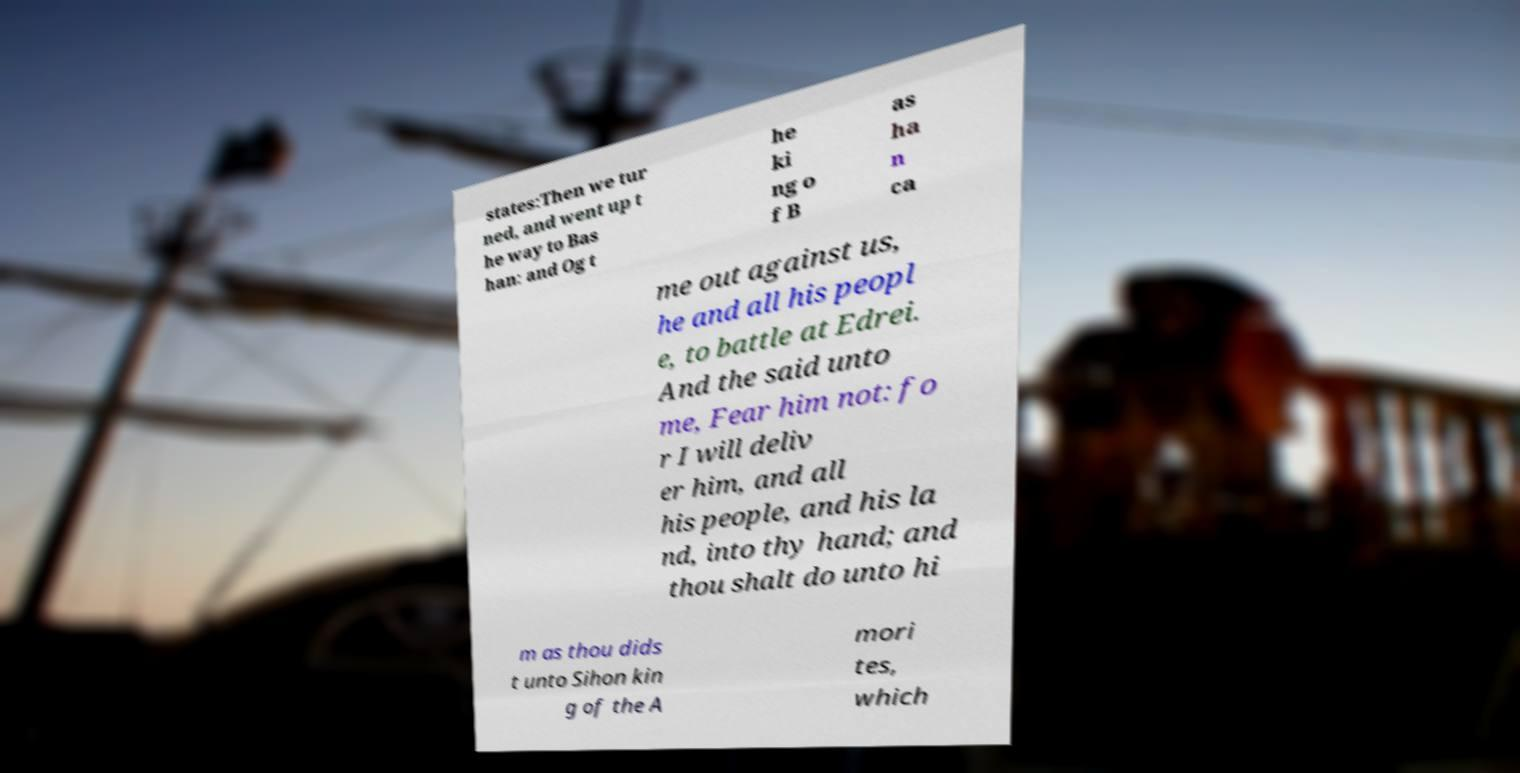I need the written content from this picture converted into text. Can you do that? states:Then we tur ned, and went up t he way to Bas han: and Og t he ki ng o f B as ha n ca me out against us, he and all his peopl e, to battle at Edrei. And the said unto me, Fear him not: fo r I will deliv er him, and all his people, and his la nd, into thy hand; and thou shalt do unto hi m as thou dids t unto Sihon kin g of the A mori tes, which 